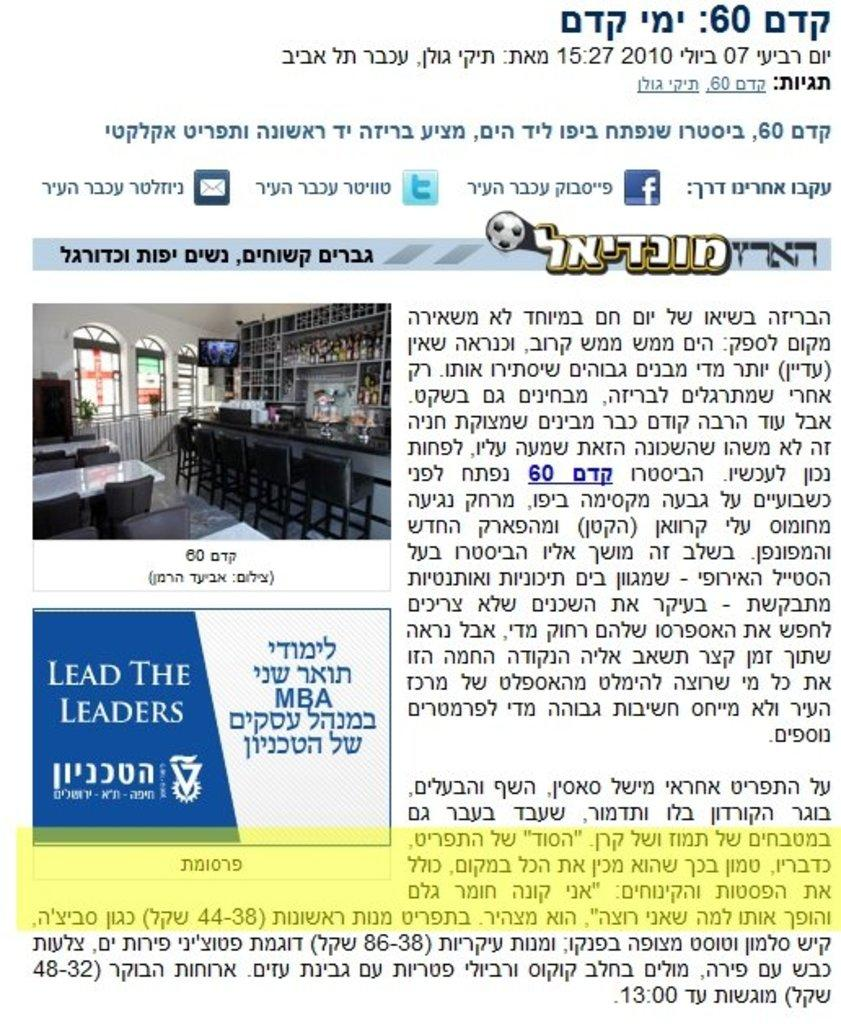<image>
Provide a brief description of the given image. Poster showing a different language and a blue logo that says Lead The Leaders. 